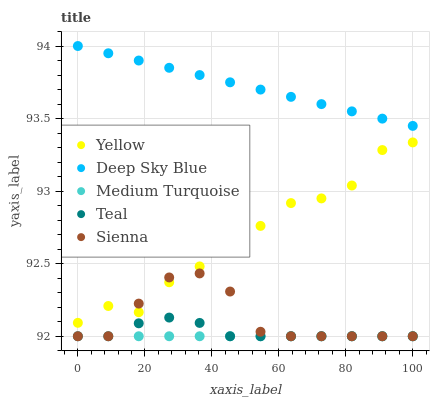Does Teal have the minimum area under the curve?
Answer yes or no. Yes. Does Deep Sky Blue have the maximum area under the curve?
Answer yes or no. Yes. Does Sienna have the minimum area under the curve?
Answer yes or no. No. Does Sienna have the maximum area under the curve?
Answer yes or no. No. Is Deep Sky Blue the smoothest?
Answer yes or no. Yes. Is Yellow the roughest?
Answer yes or no. Yes. Is Sienna the smoothest?
Answer yes or no. No. Is Sienna the roughest?
Answer yes or no. No. Does Teal have the lowest value?
Answer yes or no. Yes. Does Deep Sky Blue have the lowest value?
Answer yes or no. No. Does Deep Sky Blue have the highest value?
Answer yes or no. Yes. Does Sienna have the highest value?
Answer yes or no. No. Is Sienna less than Deep Sky Blue?
Answer yes or no. Yes. Is Deep Sky Blue greater than Medium Turquoise?
Answer yes or no. Yes. Does Sienna intersect Yellow?
Answer yes or no. Yes. Is Sienna less than Yellow?
Answer yes or no. No. Is Sienna greater than Yellow?
Answer yes or no. No. Does Sienna intersect Deep Sky Blue?
Answer yes or no. No. 